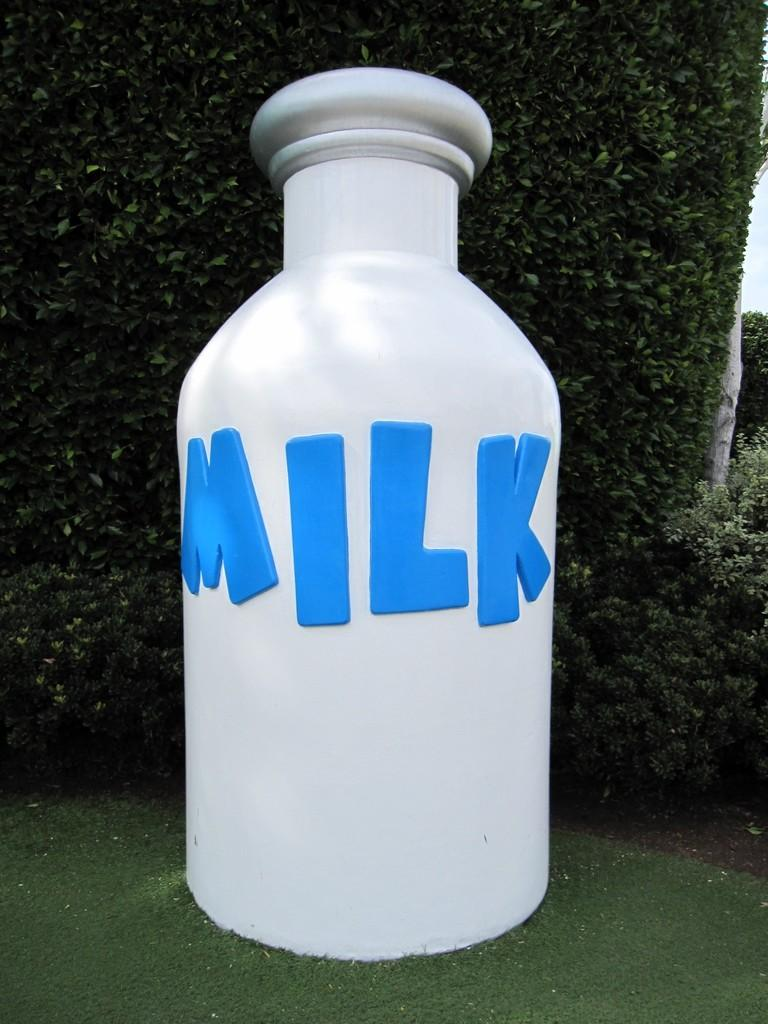<image>
Write a terse but informative summary of the picture. a huge bottle that is labeled as 'milk' in huge blue letters 